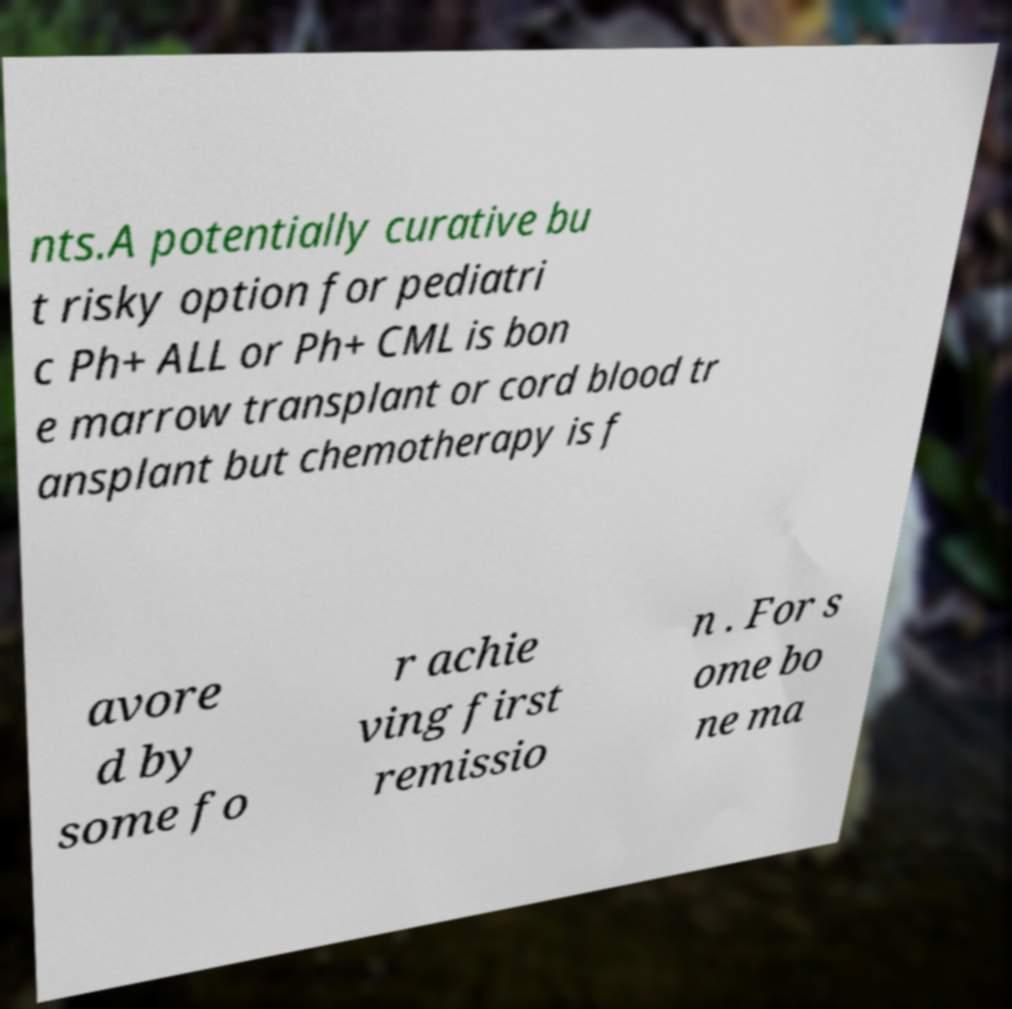What messages or text are displayed in this image? I need them in a readable, typed format. nts.A potentially curative bu t risky option for pediatri c Ph+ ALL or Ph+ CML is bon e marrow transplant or cord blood tr ansplant but chemotherapy is f avore d by some fo r achie ving first remissio n . For s ome bo ne ma 